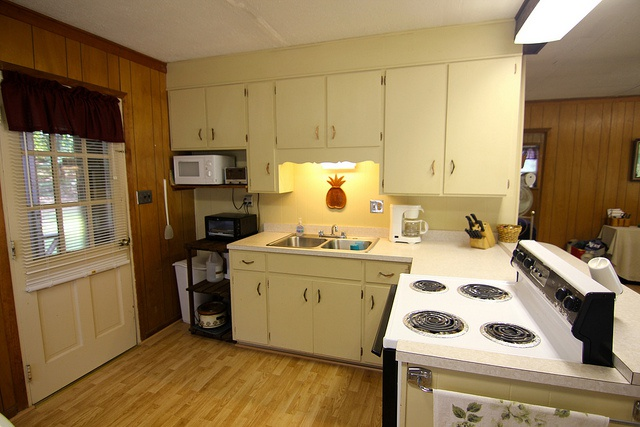Describe the objects in this image and their specific colors. I can see oven in black, ivory, darkgray, and gray tones, microwave in black, darkgray, and gray tones, sink in black, olive, khaki, and tan tones, microwave in black and gray tones, and dining table in black, olive, maroon, and gray tones in this image. 